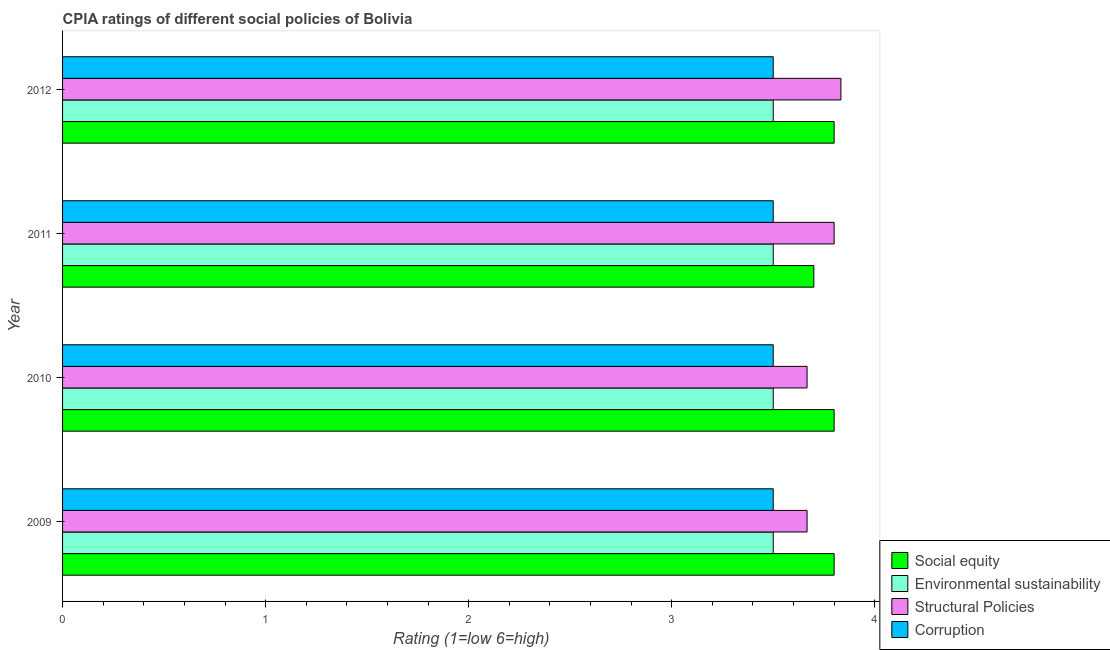How many different coloured bars are there?
Your answer should be very brief. 4. How many bars are there on the 2nd tick from the bottom?
Your response must be concise. 4. Across all years, what is the minimum cpia rating of structural policies?
Provide a succinct answer. 3.67. In which year was the cpia rating of corruption maximum?
Provide a short and direct response. 2009. What is the total cpia rating of structural policies in the graph?
Your response must be concise. 14.97. What is the difference between the cpia rating of corruption in 2012 and the cpia rating of environmental sustainability in 2011?
Provide a short and direct response. 0. In the year 2009, what is the difference between the cpia rating of structural policies and cpia rating of social equity?
Your response must be concise. -0.13. In how many years, is the cpia rating of environmental sustainability greater than 3.8 ?
Provide a succinct answer. 0. What is the ratio of the cpia rating of corruption in 2009 to that in 2012?
Provide a succinct answer. 1. Is the difference between the cpia rating of environmental sustainability in 2009 and 2010 greater than the difference between the cpia rating of social equity in 2009 and 2010?
Keep it short and to the point. No. What is the difference between the highest and the second highest cpia rating of corruption?
Offer a terse response. 0. What is the difference between the highest and the lowest cpia rating of corruption?
Give a very brief answer. 0. In how many years, is the cpia rating of corruption greater than the average cpia rating of corruption taken over all years?
Keep it short and to the point. 0. Is the sum of the cpia rating of corruption in 2011 and 2012 greater than the maximum cpia rating of environmental sustainability across all years?
Offer a very short reply. Yes. Is it the case that in every year, the sum of the cpia rating of corruption and cpia rating of social equity is greater than the sum of cpia rating of environmental sustainability and cpia rating of structural policies?
Offer a terse response. No. What does the 1st bar from the top in 2010 represents?
Give a very brief answer. Corruption. What does the 2nd bar from the bottom in 2012 represents?
Keep it short and to the point. Environmental sustainability. How many bars are there?
Your answer should be very brief. 16. Where does the legend appear in the graph?
Ensure brevity in your answer.  Bottom right. What is the title of the graph?
Offer a very short reply. CPIA ratings of different social policies of Bolivia. Does "Belgium" appear as one of the legend labels in the graph?
Offer a very short reply. No. What is the label or title of the Y-axis?
Offer a very short reply. Year. What is the Rating (1=low 6=high) of Social equity in 2009?
Keep it short and to the point. 3.8. What is the Rating (1=low 6=high) in Structural Policies in 2009?
Make the answer very short. 3.67. What is the Rating (1=low 6=high) of Structural Policies in 2010?
Provide a succinct answer. 3.67. What is the Rating (1=low 6=high) of Social equity in 2011?
Offer a very short reply. 3.7. What is the Rating (1=low 6=high) in Environmental sustainability in 2011?
Give a very brief answer. 3.5. What is the Rating (1=low 6=high) in Corruption in 2011?
Your answer should be compact. 3.5. What is the Rating (1=low 6=high) in Social equity in 2012?
Your response must be concise. 3.8. What is the Rating (1=low 6=high) of Environmental sustainability in 2012?
Provide a short and direct response. 3.5. What is the Rating (1=low 6=high) of Structural Policies in 2012?
Give a very brief answer. 3.83. What is the Rating (1=low 6=high) in Corruption in 2012?
Your answer should be very brief. 3.5. Across all years, what is the maximum Rating (1=low 6=high) in Structural Policies?
Provide a succinct answer. 3.83. Across all years, what is the maximum Rating (1=low 6=high) of Corruption?
Keep it short and to the point. 3.5. Across all years, what is the minimum Rating (1=low 6=high) of Structural Policies?
Provide a succinct answer. 3.67. What is the total Rating (1=low 6=high) of Social equity in the graph?
Your response must be concise. 15.1. What is the total Rating (1=low 6=high) of Environmental sustainability in the graph?
Provide a succinct answer. 14. What is the total Rating (1=low 6=high) in Structural Policies in the graph?
Offer a very short reply. 14.97. What is the total Rating (1=low 6=high) of Corruption in the graph?
Your response must be concise. 14. What is the difference between the Rating (1=low 6=high) of Environmental sustainability in 2009 and that in 2010?
Your answer should be compact. 0. What is the difference between the Rating (1=low 6=high) in Structural Policies in 2009 and that in 2010?
Ensure brevity in your answer.  0. What is the difference between the Rating (1=low 6=high) in Structural Policies in 2009 and that in 2011?
Provide a short and direct response. -0.13. What is the difference between the Rating (1=low 6=high) of Environmental sustainability in 2009 and that in 2012?
Your answer should be compact. 0. What is the difference between the Rating (1=low 6=high) in Social equity in 2010 and that in 2011?
Ensure brevity in your answer.  0.1. What is the difference between the Rating (1=low 6=high) in Structural Policies in 2010 and that in 2011?
Your answer should be very brief. -0.13. What is the difference between the Rating (1=low 6=high) of Corruption in 2010 and that in 2011?
Your answer should be very brief. 0. What is the difference between the Rating (1=low 6=high) of Social equity in 2010 and that in 2012?
Provide a succinct answer. 0. What is the difference between the Rating (1=low 6=high) in Environmental sustainability in 2010 and that in 2012?
Make the answer very short. 0. What is the difference between the Rating (1=low 6=high) in Structural Policies in 2010 and that in 2012?
Make the answer very short. -0.17. What is the difference between the Rating (1=low 6=high) in Structural Policies in 2011 and that in 2012?
Your response must be concise. -0.03. What is the difference between the Rating (1=low 6=high) of Social equity in 2009 and the Rating (1=low 6=high) of Environmental sustainability in 2010?
Keep it short and to the point. 0.3. What is the difference between the Rating (1=low 6=high) in Social equity in 2009 and the Rating (1=low 6=high) in Structural Policies in 2010?
Your answer should be compact. 0.13. What is the difference between the Rating (1=low 6=high) of Environmental sustainability in 2009 and the Rating (1=low 6=high) of Structural Policies in 2010?
Your answer should be very brief. -0.17. What is the difference between the Rating (1=low 6=high) of Structural Policies in 2009 and the Rating (1=low 6=high) of Corruption in 2010?
Your response must be concise. 0.17. What is the difference between the Rating (1=low 6=high) in Social equity in 2009 and the Rating (1=low 6=high) in Corruption in 2011?
Provide a short and direct response. 0.3. What is the difference between the Rating (1=low 6=high) of Environmental sustainability in 2009 and the Rating (1=low 6=high) of Corruption in 2011?
Make the answer very short. 0. What is the difference between the Rating (1=low 6=high) of Structural Policies in 2009 and the Rating (1=low 6=high) of Corruption in 2011?
Your answer should be compact. 0.17. What is the difference between the Rating (1=low 6=high) of Social equity in 2009 and the Rating (1=low 6=high) of Environmental sustainability in 2012?
Make the answer very short. 0.3. What is the difference between the Rating (1=low 6=high) of Social equity in 2009 and the Rating (1=low 6=high) of Structural Policies in 2012?
Make the answer very short. -0.03. What is the difference between the Rating (1=low 6=high) in Social equity in 2009 and the Rating (1=low 6=high) in Corruption in 2012?
Keep it short and to the point. 0.3. What is the difference between the Rating (1=low 6=high) of Environmental sustainability in 2009 and the Rating (1=low 6=high) of Corruption in 2012?
Your answer should be very brief. 0. What is the difference between the Rating (1=low 6=high) in Social equity in 2010 and the Rating (1=low 6=high) in Corruption in 2011?
Your response must be concise. 0.3. What is the difference between the Rating (1=low 6=high) in Environmental sustainability in 2010 and the Rating (1=low 6=high) in Structural Policies in 2011?
Provide a short and direct response. -0.3. What is the difference between the Rating (1=low 6=high) in Structural Policies in 2010 and the Rating (1=low 6=high) in Corruption in 2011?
Provide a short and direct response. 0.17. What is the difference between the Rating (1=low 6=high) in Social equity in 2010 and the Rating (1=low 6=high) in Structural Policies in 2012?
Provide a succinct answer. -0.03. What is the difference between the Rating (1=low 6=high) of Social equity in 2010 and the Rating (1=low 6=high) of Corruption in 2012?
Offer a terse response. 0.3. What is the difference between the Rating (1=low 6=high) in Environmental sustainability in 2010 and the Rating (1=low 6=high) in Corruption in 2012?
Provide a succinct answer. 0. What is the difference between the Rating (1=low 6=high) of Structural Policies in 2010 and the Rating (1=low 6=high) of Corruption in 2012?
Give a very brief answer. 0.17. What is the difference between the Rating (1=low 6=high) of Social equity in 2011 and the Rating (1=low 6=high) of Structural Policies in 2012?
Keep it short and to the point. -0.13. What is the difference between the Rating (1=low 6=high) of Social equity in 2011 and the Rating (1=low 6=high) of Corruption in 2012?
Your response must be concise. 0.2. What is the difference between the Rating (1=low 6=high) in Environmental sustainability in 2011 and the Rating (1=low 6=high) in Structural Policies in 2012?
Make the answer very short. -0.33. What is the difference between the Rating (1=low 6=high) in Environmental sustainability in 2011 and the Rating (1=low 6=high) in Corruption in 2012?
Your response must be concise. 0. What is the difference between the Rating (1=low 6=high) of Structural Policies in 2011 and the Rating (1=low 6=high) of Corruption in 2012?
Provide a succinct answer. 0.3. What is the average Rating (1=low 6=high) of Social equity per year?
Keep it short and to the point. 3.77. What is the average Rating (1=low 6=high) of Environmental sustainability per year?
Your answer should be compact. 3.5. What is the average Rating (1=low 6=high) of Structural Policies per year?
Ensure brevity in your answer.  3.74. What is the average Rating (1=low 6=high) of Corruption per year?
Provide a succinct answer. 3.5. In the year 2009, what is the difference between the Rating (1=low 6=high) in Social equity and Rating (1=low 6=high) in Environmental sustainability?
Provide a short and direct response. 0.3. In the year 2009, what is the difference between the Rating (1=low 6=high) in Social equity and Rating (1=low 6=high) in Structural Policies?
Your answer should be very brief. 0.13. In the year 2009, what is the difference between the Rating (1=low 6=high) of Environmental sustainability and Rating (1=low 6=high) of Corruption?
Offer a very short reply. 0. In the year 2010, what is the difference between the Rating (1=low 6=high) of Social equity and Rating (1=low 6=high) of Structural Policies?
Offer a very short reply. 0.13. In the year 2010, what is the difference between the Rating (1=low 6=high) of Environmental sustainability and Rating (1=low 6=high) of Structural Policies?
Offer a terse response. -0.17. In the year 2010, what is the difference between the Rating (1=low 6=high) of Environmental sustainability and Rating (1=low 6=high) of Corruption?
Keep it short and to the point. 0. In the year 2011, what is the difference between the Rating (1=low 6=high) of Social equity and Rating (1=low 6=high) of Environmental sustainability?
Offer a terse response. 0.2. In the year 2011, what is the difference between the Rating (1=low 6=high) of Social equity and Rating (1=low 6=high) of Structural Policies?
Your answer should be compact. -0.1. In the year 2011, what is the difference between the Rating (1=low 6=high) in Environmental sustainability and Rating (1=low 6=high) in Structural Policies?
Keep it short and to the point. -0.3. In the year 2011, what is the difference between the Rating (1=low 6=high) in Structural Policies and Rating (1=low 6=high) in Corruption?
Provide a succinct answer. 0.3. In the year 2012, what is the difference between the Rating (1=low 6=high) of Social equity and Rating (1=low 6=high) of Environmental sustainability?
Give a very brief answer. 0.3. In the year 2012, what is the difference between the Rating (1=low 6=high) of Social equity and Rating (1=low 6=high) of Structural Policies?
Make the answer very short. -0.03. In the year 2012, what is the difference between the Rating (1=low 6=high) in Environmental sustainability and Rating (1=low 6=high) in Structural Policies?
Your response must be concise. -0.33. In the year 2012, what is the difference between the Rating (1=low 6=high) in Environmental sustainability and Rating (1=low 6=high) in Corruption?
Your answer should be compact. 0. What is the ratio of the Rating (1=low 6=high) in Structural Policies in 2009 to that in 2010?
Your answer should be compact. 1. What is the ratio of the Rating (1=low 6=high) in Corruption in 2009 to that in 2010?
Provide a succinct answer. 1. What is the ratio of the Rating (1=low 6=high) in Structural Policies in 2009 to that in 2011?
Give a very brief answer. 0.96. What is the ratio of the Rating (1=low 6=high) of Corruption in 2009 to that in 2011?
Ensure brevity in your answer.  1. What is the ratio of the Rating (1=low 6=high) in Environmental sustainability in 2009 to that in 2012?
Offer a very short reply. 1. What is the ratio of the Rating (1=low 6=high) in Structural Policies in 2009 to that in 2012?
Provide a short and direct response. 0.96. What is the ratio of the Rating (1=low 6=high) of Social equity in 2010 to that in 2011?
Offer a very short reply. 1.03. What is the ratio of the Rating (1=low 6=high) of Structural Policies in 2010 to that in 2011?
Give a very brief answer. 0.96. What is the ratio of the Rating (1=low 6=high) of Corruption in 2010 to that in 2011?
Ensure brevity in your answer.  1. What is the ratio of the Rating (1=low 6=high) of Social equity in 2010 to that in 2012?
Offer a terse response. 1. What is the ratio of the Rating (1=low 6=high) in Environmental sustainability in 2010 to that in 2012?
Keep it short and to the point. 1. What is the ratio of the Rating (1=low 6=high) in Structural Policies in 2010 to that in 2012?
Offer a terse response. 0.96. What is the ratio of the Rating (1=low 6=high) in Corruption in 2010 to that in 2012?
Provide a succinct answer. 1. What is the ratio of the Rating (1=low 6=high) in Social equity in 2011 to that in 2012?
Keep it short and to the point. 0.97. What is the ratio of the Rating (1=low 6=high) in Environmental sustainability in 2011 to that in 2012?
Your answer should be compact. 1. What is the difference between the highest and the lowest Rating (1=low 6=high) in Social equity?
Your answer should be very brief. 0.1. What is the difference between the highest and the lowest Rating (1=low 6=high) of Environmental sustainability?
Make the answer very short. 0. What is the difference between the highest and the lowest Rating (1=low 6=high) of Structural Policies?
Make the answer very short. 0.17. 